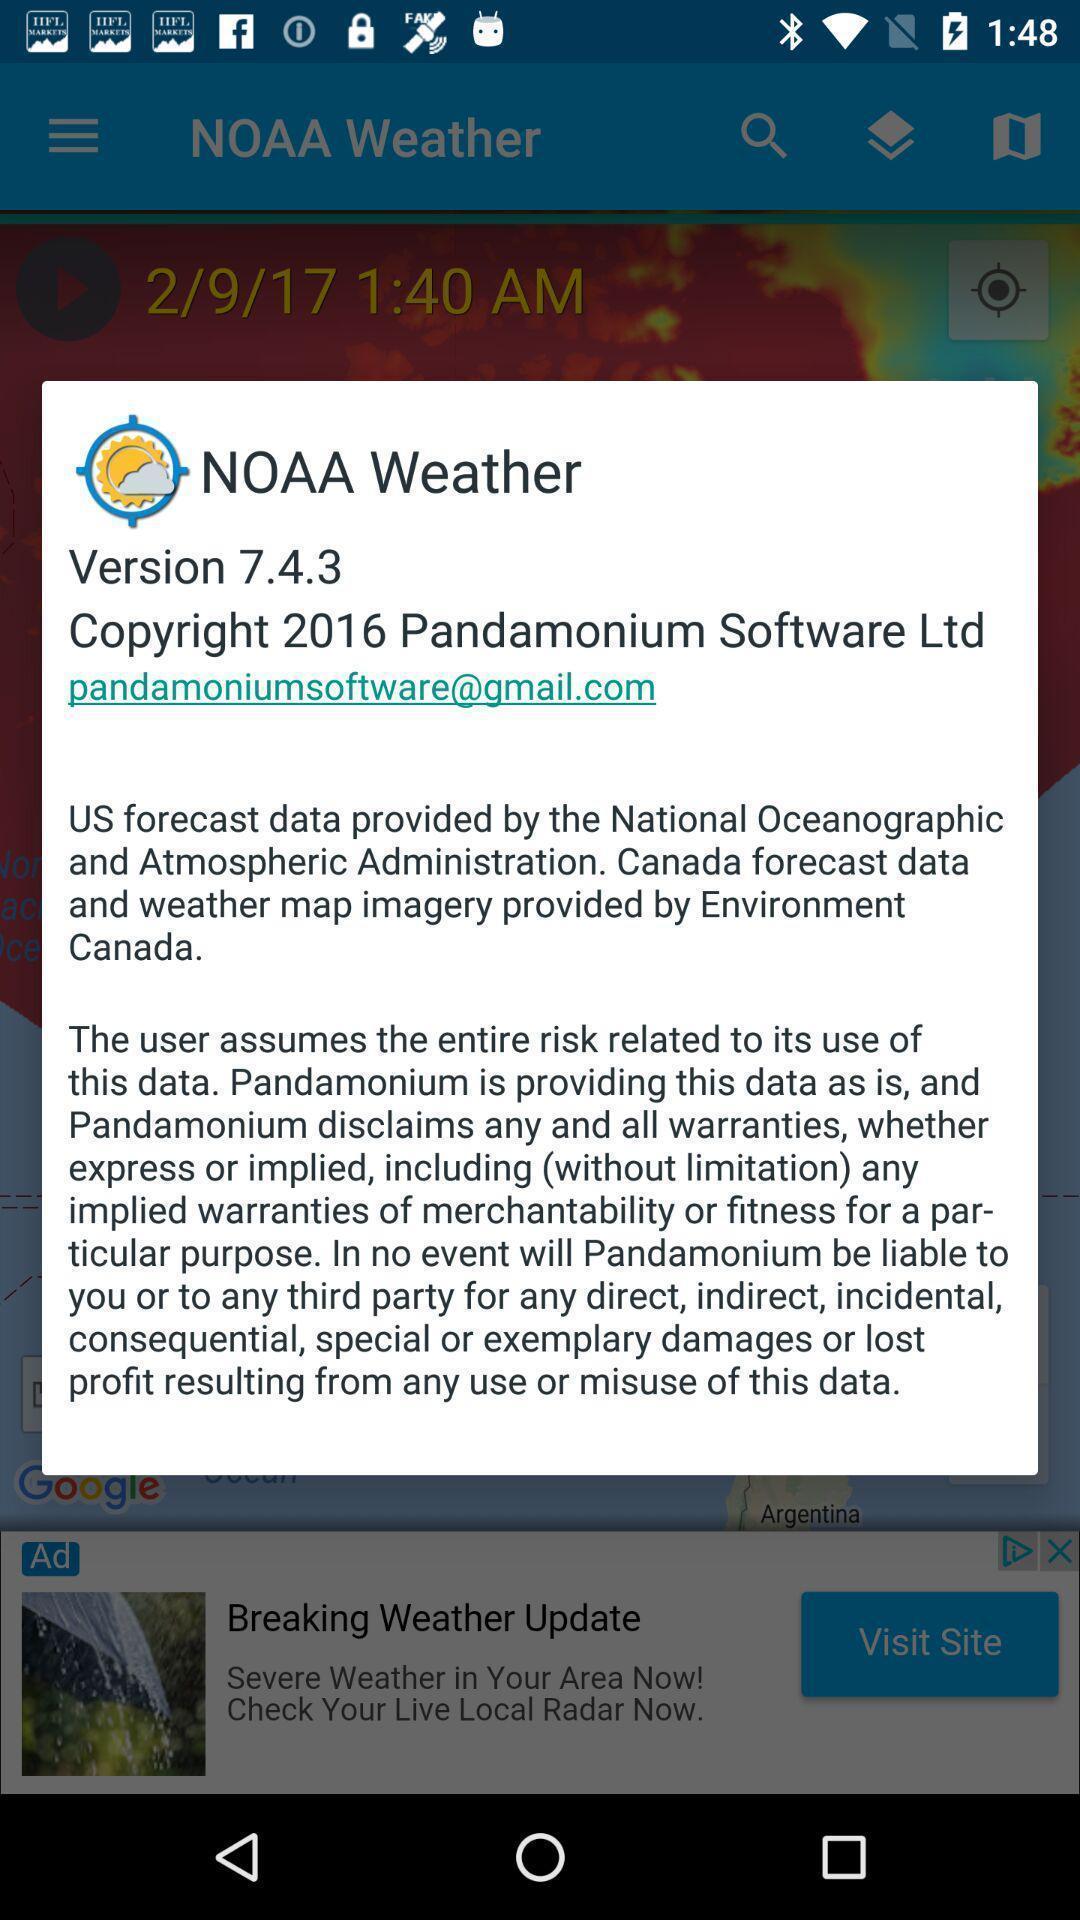Summarize the information in this screenshot. Popup of the description regarding application version. 